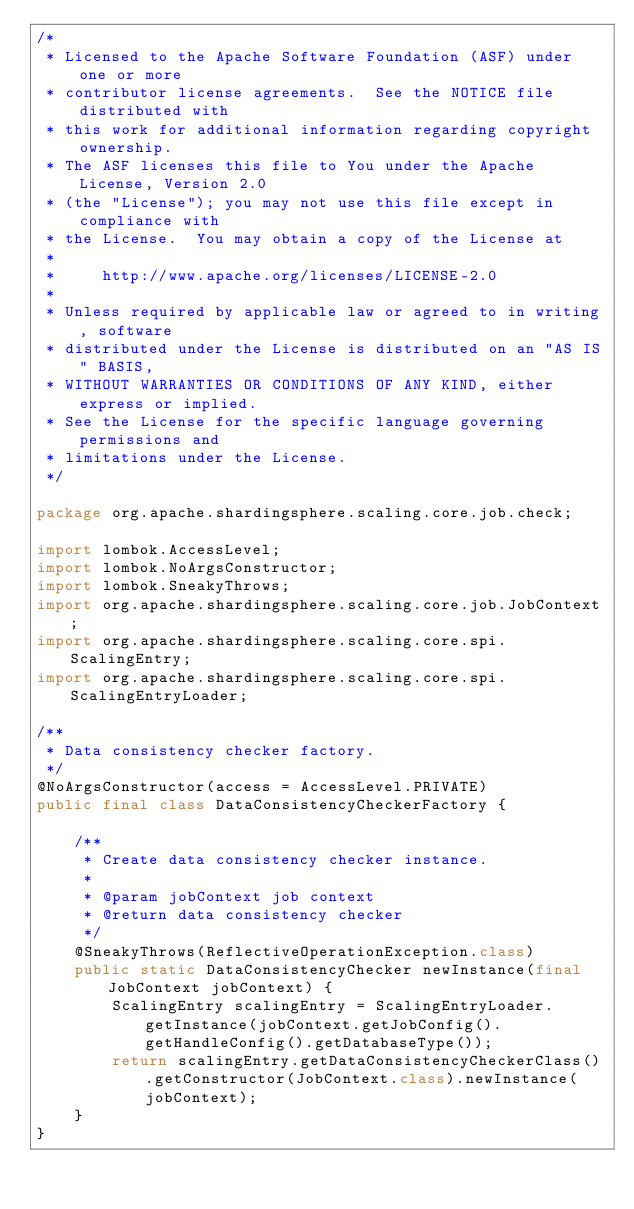Convert code to text. <code><loc_0><loc_0><loc_500><loc_500><_Java_>/*
 * Licensed to the Apache Software Foundation (ASF) under one or more
 * contributor license agreements.  See the NOTICE file distributed with
 * this work for additional information regarding copyright ownership.
 * The ASF licenses this file to You under the Apache License, Version 2.0
 * (the "License"); you may not use this file except in compliance with
 * the License.  You may obtain a copy of the License at
 *
 *     http://www.apache.org/licenses/LICENSE-2.0
 *
 * Unless required by applicable law or agreed to in writing, software
 * distributed under the License is distributed on an "AS IS" BASIS,
 * WITHOUT WARRANTIES OR CONDITIONS OF ANY KIND, either express or implied.
 * See the License for the specific language governing permissions and
 * limitations under the License.
 */

package org.apache.shardingsphere.scaling.core.job.check;

import lombok.AccessLevel;
import lombok.NoArgsConstructor;
import lombok.SneakyThrows;
import org.apache.shardingsphere.scaling.core.job.JobContext;
import org.apache.shardingsphere.scaling.core.spi.ScalingEntry;
import org.apache.shardingsphere.scaling.core.spi.ScalingEntryLoader;

/**
 * Data consistency checker factory.
 */
@NoArgsConstructor(access = AccessLevel.PRIVATE)
public final class DataConsistencyCheckerFactory {
    
    /**
     * Create data consistency checker instance.
     *
     * @param jobContext job context
     * @return data consistency checker
     */
    @SneakyThrows(ReflectiveOperationException.class)
    public static DataConsistencyChecker newInstance(final JobContext jobContext) {
        ScalingEntry scalingEntry = ScalingEntryLoader.getInstance(jobContext.getJobConfig().getHandleConfig().getDatabaseType());
        return scalingEntry.getDataConsistencyCheckerClass().getConstructor(JobContext.class).newInstance(jobContext);
    }
}
</code> 